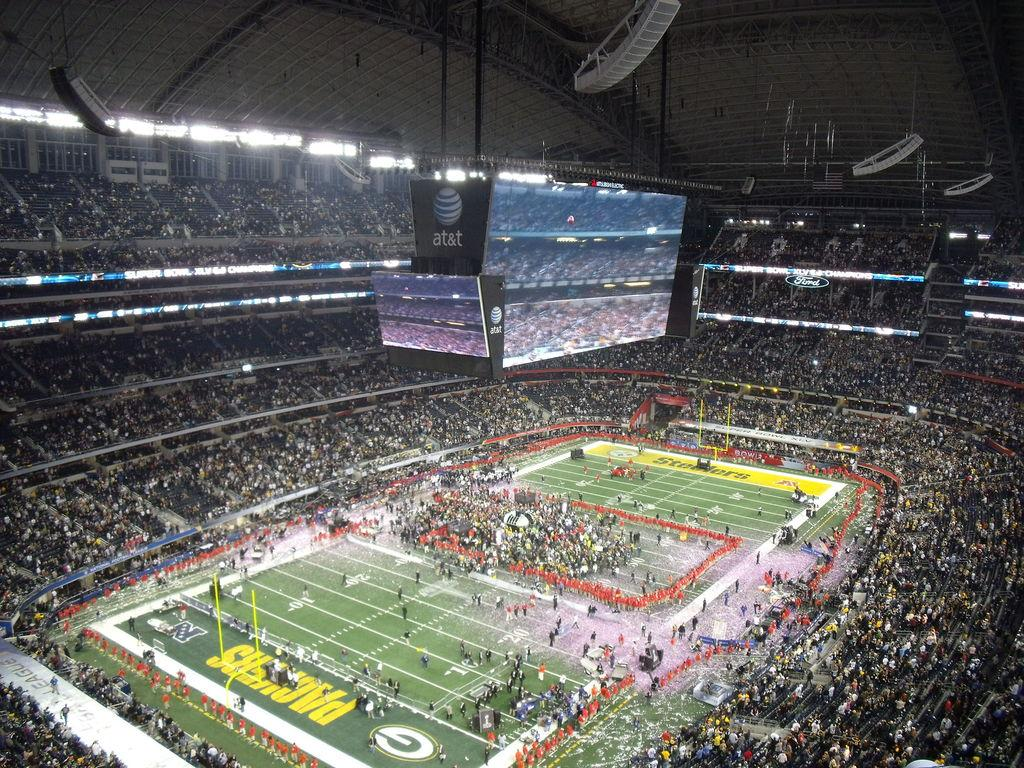What type of structure is visible in the image? There is a stadium in the image. What can be seen inside the stadium? There are audience members around the ground in the stadium. What type of head is being used by the expert in the company in the image? There is no mention of an expert or a company in the image, and therefore no such information can be provided. 